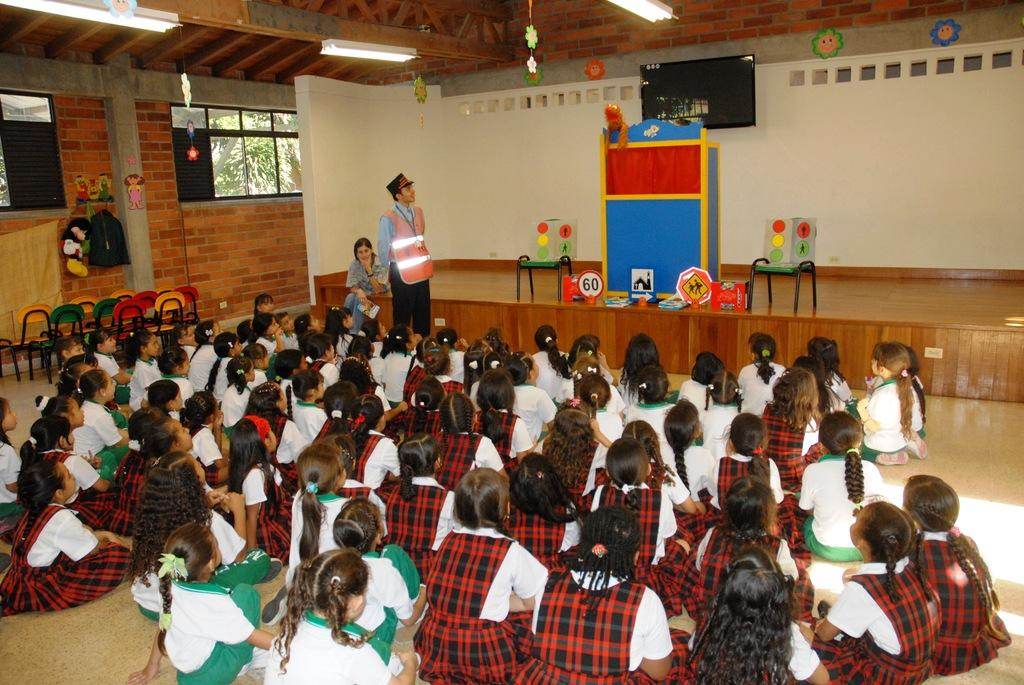What are the children in the image doing? The children are sitting on the ground in the image. Who else is present in the image besides the children? There is a man standing in the image. What type of furniture can be seen in the image? There are chairs in the image. What structure is present for presentations or speeches? There is a podium in the image. What device is used for displaying information or visuals? There is a display screen in the image. What type of lighting is present in the image? Electric lights are present in the image. What additional decorations can be seen in the image? Decorations are visible in the image. What type of natural elements are present in the image? Trees are present in the image. What shape is the cannon in the image? There is no cannon present in the image. What type of writing can be seen on the display screen in the image? The provided facts do not mention any writing on the display screen, so we cannot determine its content from the image. 